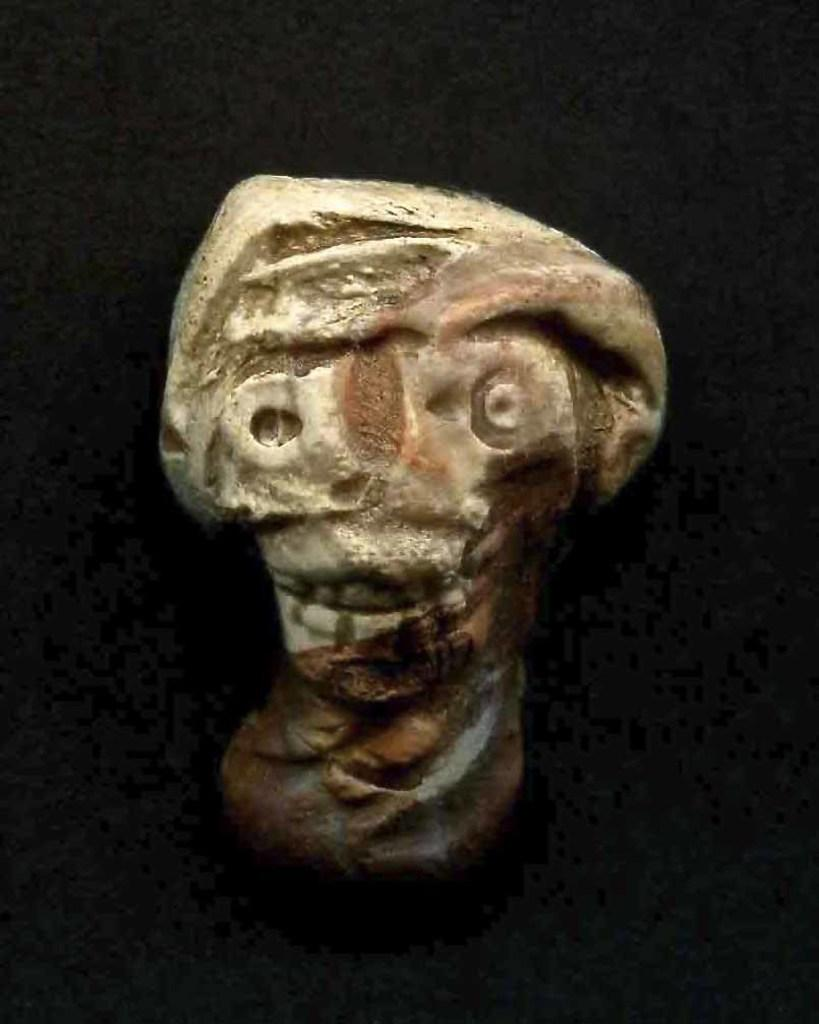What is the main object in the image? There is a cream and brown color object in the image. What color is the background of the image? The background of the image is black. How many worms can be seen crawling on the base in the image? There are no worms or bases present in the image; it only features a cream and brown color object against a black background. 